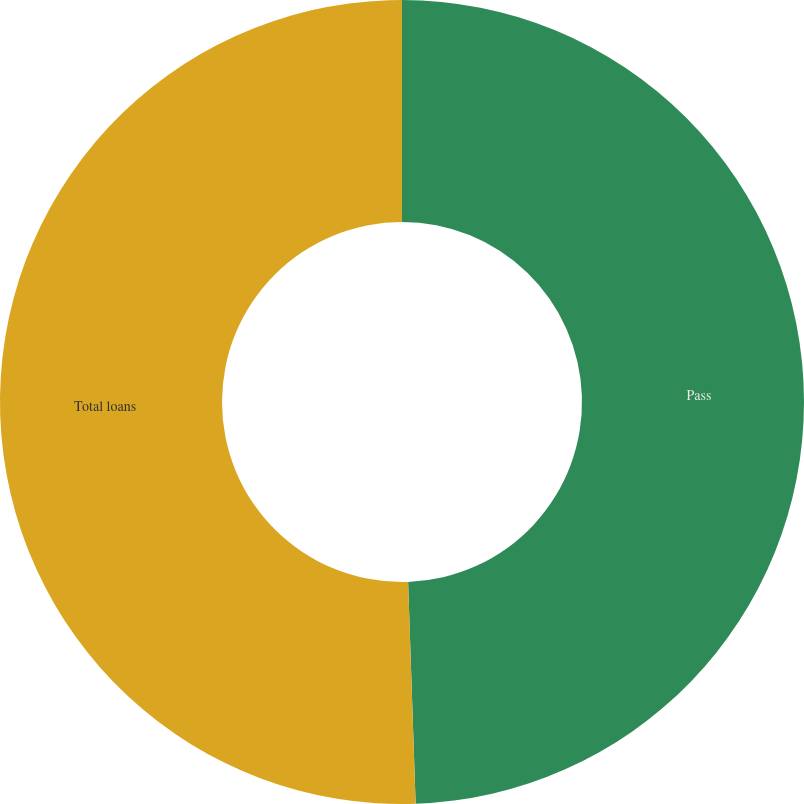Convert chart. <chart><loc_0><loc_0><loc_500><loc_500><pie_chart><fcel>Pass<fcel>Total loans<nl><fcel>49.46%<fcel>50.54%<nl></chart> 